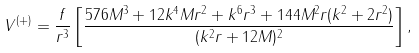Convert formula to latex. <formula><loc_0><loc_0><loc_500><loc_500>V ^ { ( + ) } = \frac { f } { r ^ { 3 } } \left [ \frac { 5 7 6 M ^ { 3 } + 1 2 k ^ { 4 } M r ^ { 2 } + k ^ { 6 } r ^ { 3 } + 1 4 4 M ^ { 2 } r ( k ^ { 2 } + 2 r ^ { 2 } ) } { ( k ^ { 2 } r + 1 2 M ) ^ { 2 } } \right ] ,</formula> 